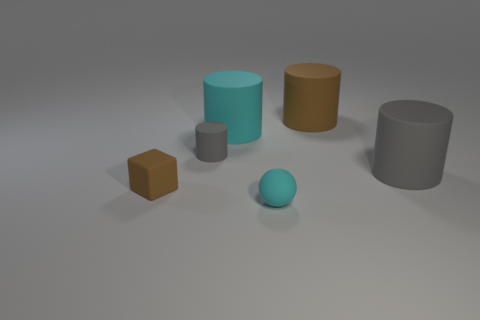What might be the context or purpose of this arrangement of objects? This appears to be a simple 3D rendering used to compare shapes and colors, perhaps made for a basic visual exercise or as part of a tutorial to demonstrate 3D modeling, shading, and lighting effects. 